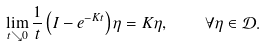<formula> <loc_0><loc_0><loc_500><loc_500>\lim _ { t \searrow 0 } \frac { 1 } { t } \left ( I - e ^ { - K t } \right ) \eta = K \eta , \quad \forall \eta \in \mathcal { D } .</formula> 